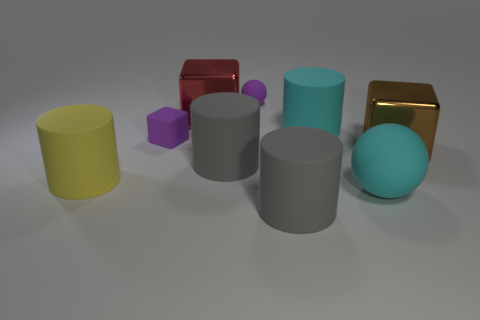Add 1 big red metal objects. How many objects exist? 10 Subtract all cubes. How many objects are left? 6 Add 5 large cylinders. How many large cylinders are left? 9 Add 2 tiny gray metallic cylinders. How many tiny gray metallic cylinders exist? 2 Subtract 0 gray blocks. How many objects are left? 9 Subtract all large shiny blocks. Subtract all large yellow cylinders. How many objects are left? 6 